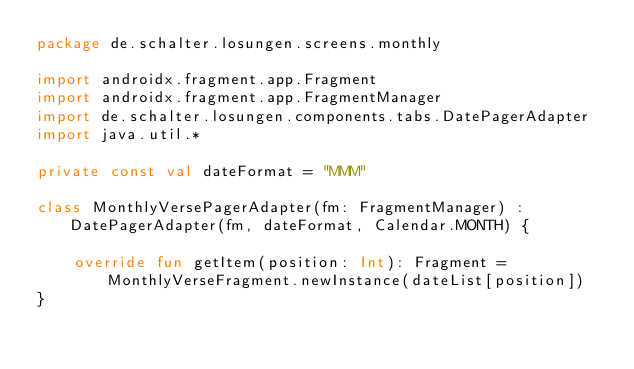Convert code to text. <code><loc_0><loc_0><loc_500><loc_500><_Kotlin_>package de.schalter.losungen.screens.monthly

import androidx.fragment.app.Fragment
import androidx.fragment.app.FragmentManager
import de.schalter.losungen.components.tabs.DatePagerAdapter
import java.util.*

private const val dateFormat = "MMM"

class MonthlyVersePagerAdapter(fm: FragmentManager) : DatePagerAdapter(fm, dateFormat, Calendar.MONTH) {

    override fun getItem(position: Int): Fragment = MonthlyVerseFragment.newInstance(dateList[position])
}</code> 